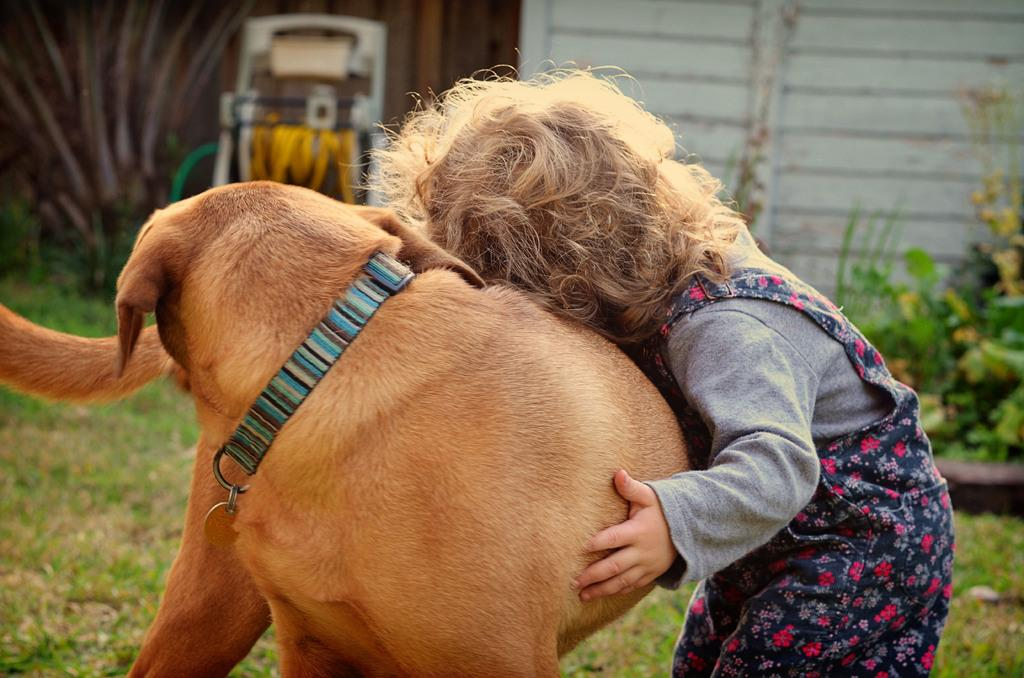Who or what is the main subject in the image? There is a small girl and a dog in the image. What are the girl and the dog doing in the image? The girl and the dog are in the middle of the image, but their specific actions are not mentioned in the facts. What can be seen in the background of the image? There are plants and a wall in the background of the image. What object related to lawn care is visible in the image? There is a grass mower in the image. What type of scissors is the girl using to cut the yoke in the image? There is no mention of scissors or a yoke in the image; the girl and the dog are the main subjects, and they are accompanied by plants, a wall, and a grass mower in the background. 